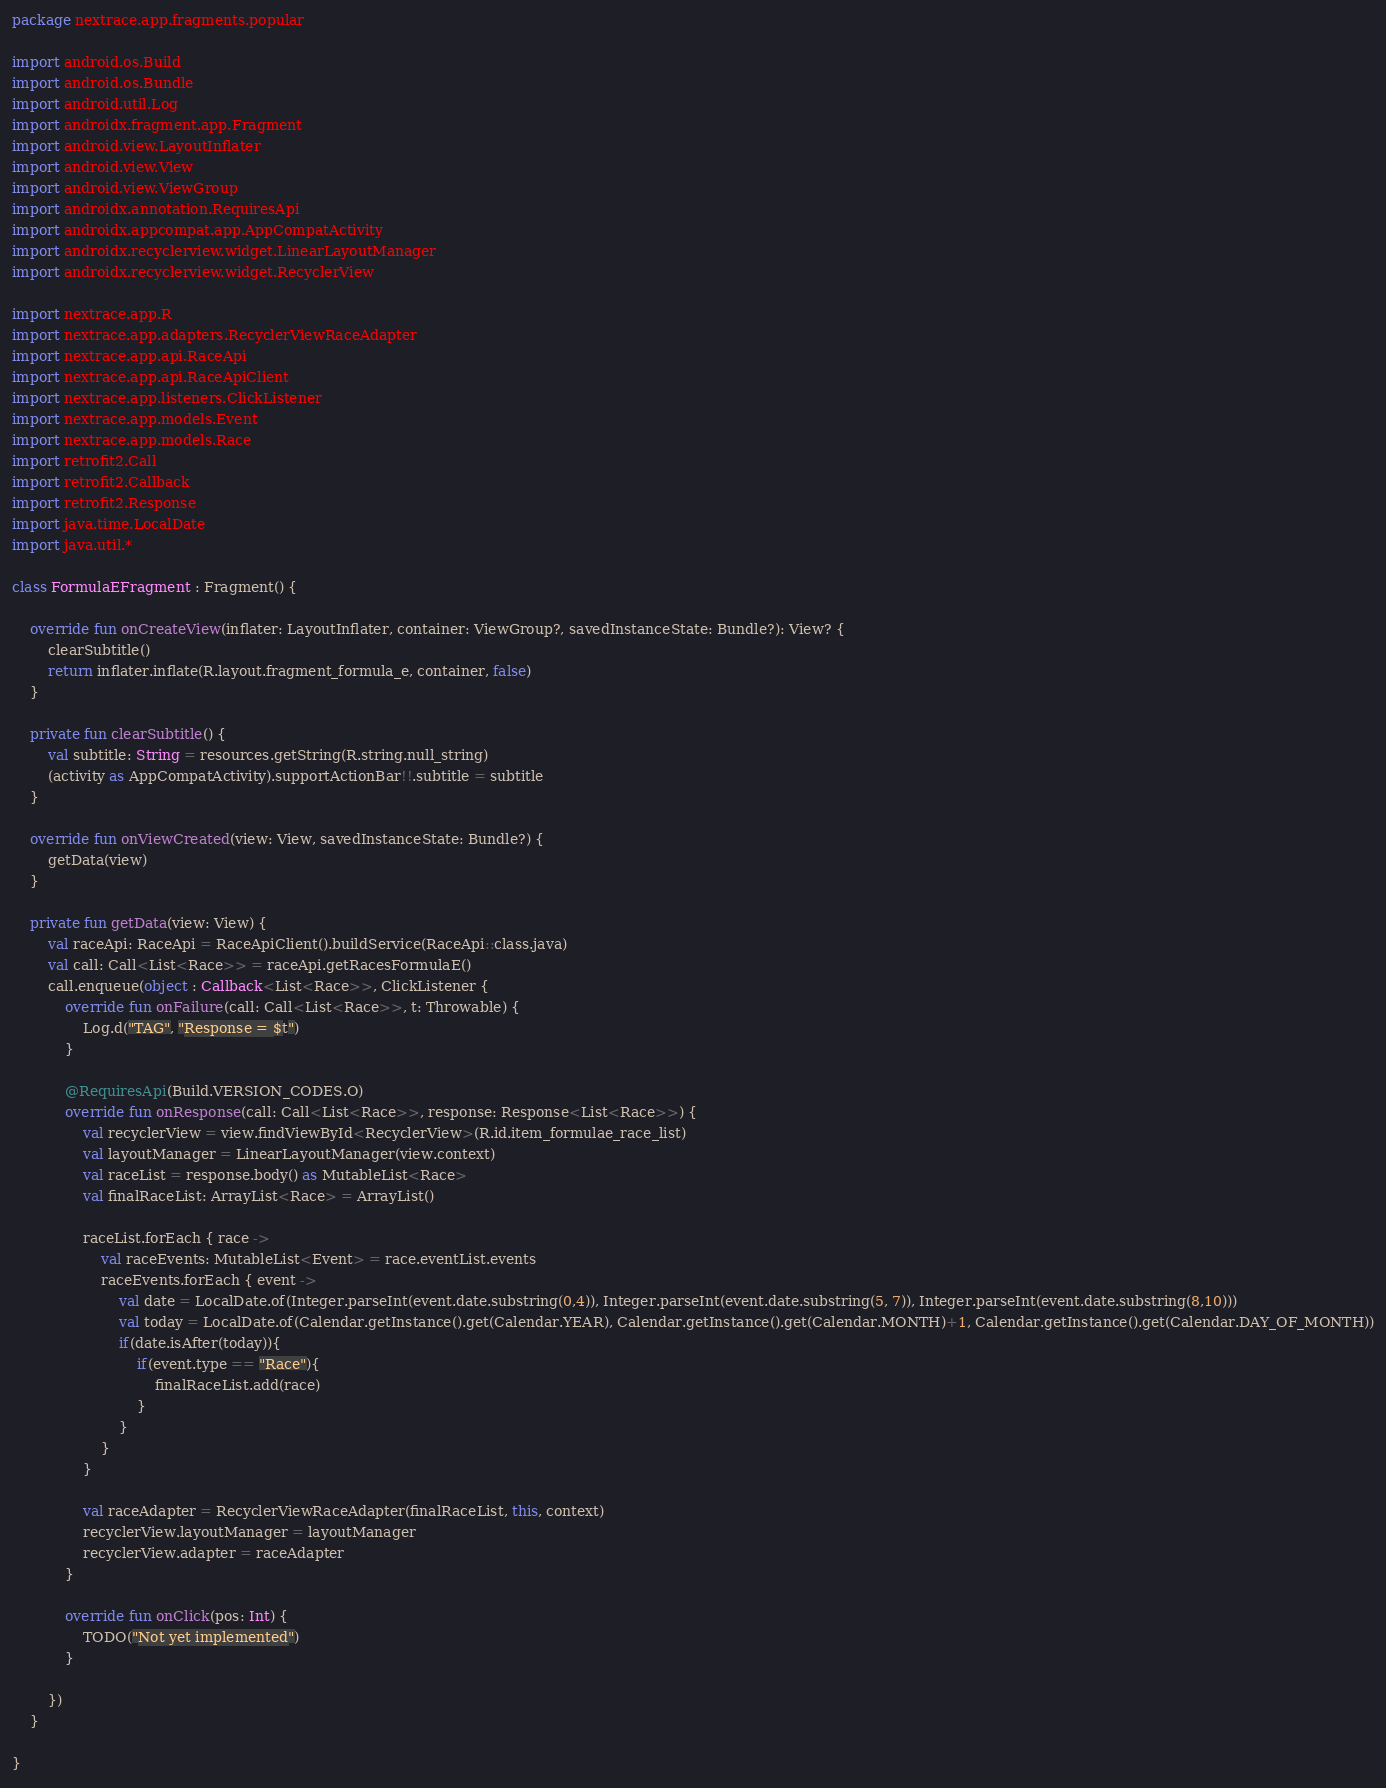Convert code to text. <code><loc_0><loc_0><loc_500><loc_500><_Kotlin_>package nextrace.app.fragments.popular

import android.os.Build
import android.os.Bundle
import android.util.Log
import androidx.fragment.app.Fragment
import android.view.LayoutInflater
import android.view.View
import android.view.ViewGroup
import androidx.annotation.RequiresApi
import androidx.appcompat.app.AppCompatActivity
import androidx.recyclerview.widget.LinearLayoutManager
import androidx.recyclerview.widget.RecyclerView

import nextrace.app.R
import nextrace.app.adapters.RecyclerViewRaceAdapter
import nextrace.app.api.RaceApi
import nextrace.app.api.RaceApiClient
import nextrace.app.listeners.ClickListener
import nextrace.app.models.Event
import nextrace.app.models.Race
import retrofit2.Call
import retrofit2.Callback
import retrofit2.Response
import java.time.LocalDate
import java.util.*

class FormulaEFragment : Fragment() {

    override fun onCreateView(inflater: LayoutInflater, container: ViewGroup?, savedInstanceState: Bundle?): View? {
        clearSubtitle()
        return inflater.inflate(R.layout.fragment_formula_e, container, false)
    }

    private fun clearSubtitle() {
        val subtitle: String = resources.getString(R.string.null_string)
        (activity as AppCompatActivity).supportActionBar!!.subtitle = subtitle
    }

    override fun onViewCreated(view: View, savedInstanceState: Bundle?) {
        getData(view)
    }

    private fun getData(view: View) {
        val raceApi: RaceApi = RaceApiClient().buildService(RaceApi::class.java)
        val call: Call<List<Race>> = raceApi.getRacesFormulaE()
        call.enqueue(object : Callback<List<Race>>, ClickListener {
            override fun onFailure(call: Call<List<Race>>, t: Throwable) {
                Log.d("TAG", "Response = $t")
            }

            @RequiresApi(Build.VERSION_CODES.O)
            override fun onResponse(call: Call<List<Race>>, response: Response<List<Race>>) {
                val recyclerView = view.findViewById<RecyclerView>(R.id.item_formulae_race_list)
                val layoutManager = LinearLayoutManager(view.context)
                val raceList = response.body() as MutableList<Race>
                val finalRaceList: ArrayList<Race> = ArrayList()

                raceList.forEach { race ->
                    val raceEvents: MutableList<Event> = race.eventList.events
                    raceEvents.forEach { event ->
                        val date = LocalDate.of(Integer.parseInt(event.date.substring(0,4)), Integer.parseInt(event.date.substring(5, 7)), Integer.parseInt(event.date.substring(8,10)))
                        val today = LocalDate.of(Calendar.getInstance().get(Calendar.YEAR), Calendar.getInstance().get(Calendar.MONTH)+1, Calendar.getInstance().get(Calendar.DAY_OF_MONTH))
                        if(date.isAfter(today)){
                            if(event.type == "Race"){
                                finalRaceList.add(race)
                            }
                        }
                    }
                }

                val raceAdapter = RecyclerViewRaceAdapter(finalRaceList, this, context)
                recyclerView.layoutManager = layoutManager
                recyclerView.adapter = raceAdapter
            }

            override fun onClick(pos: Int) {
                TODO("Not yet implemented")
            }

        })
    }

}
</code> 